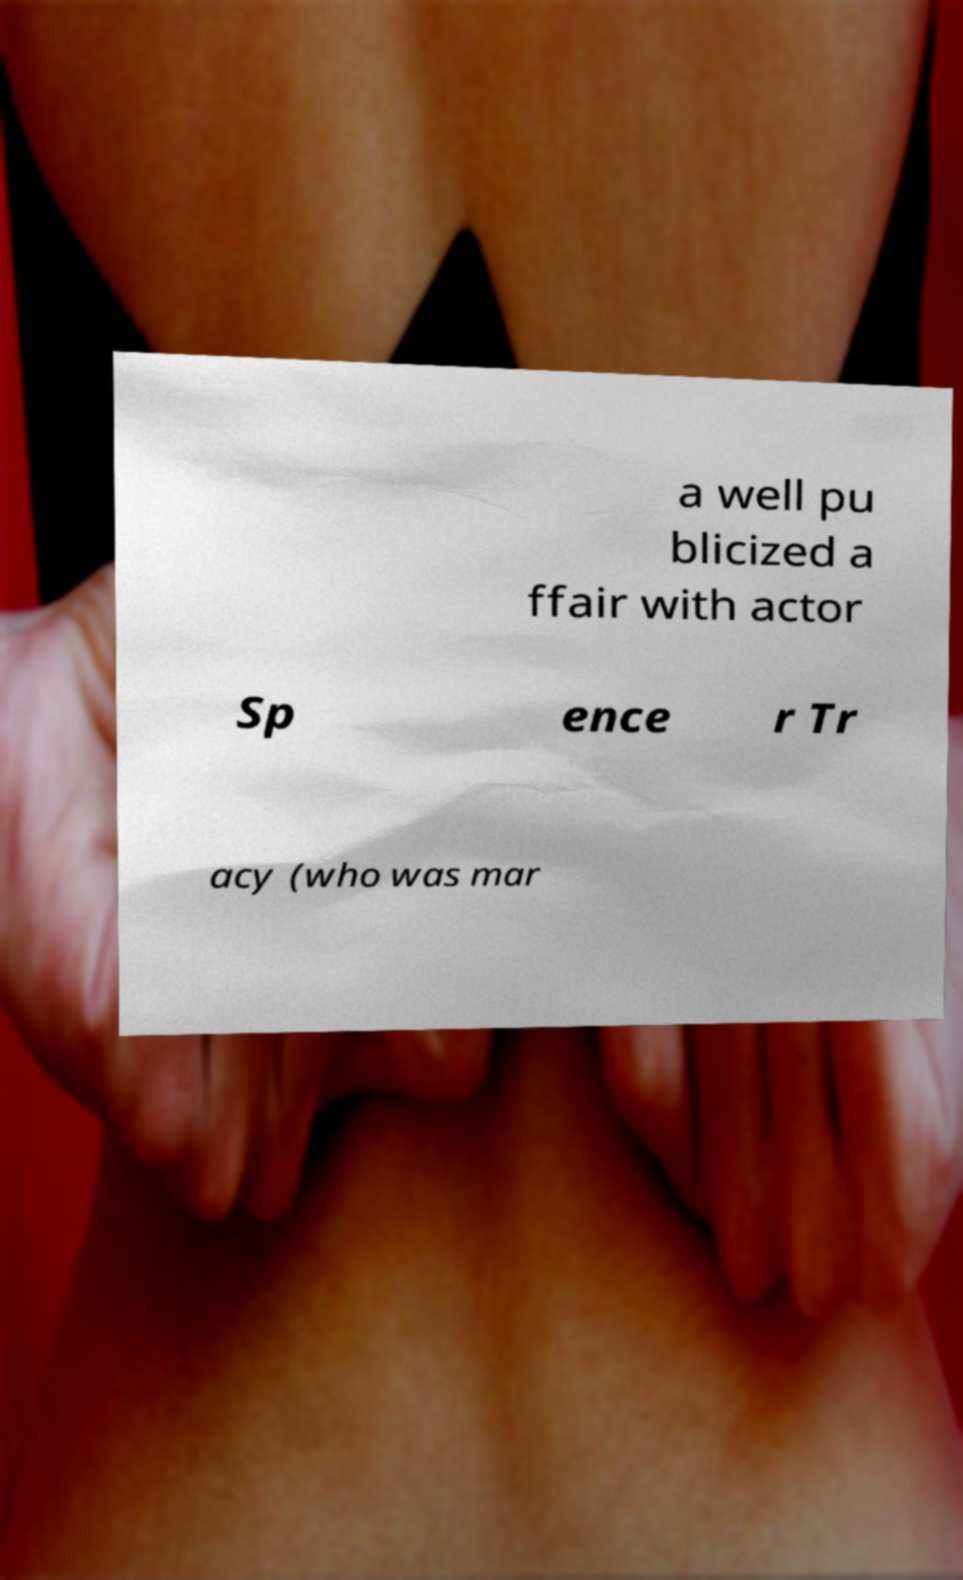Could you assist in decoding the text presented in this image and type it out clearly? a well pu blicized a ffair with actor Sp ence r Tr acy (who was mar 